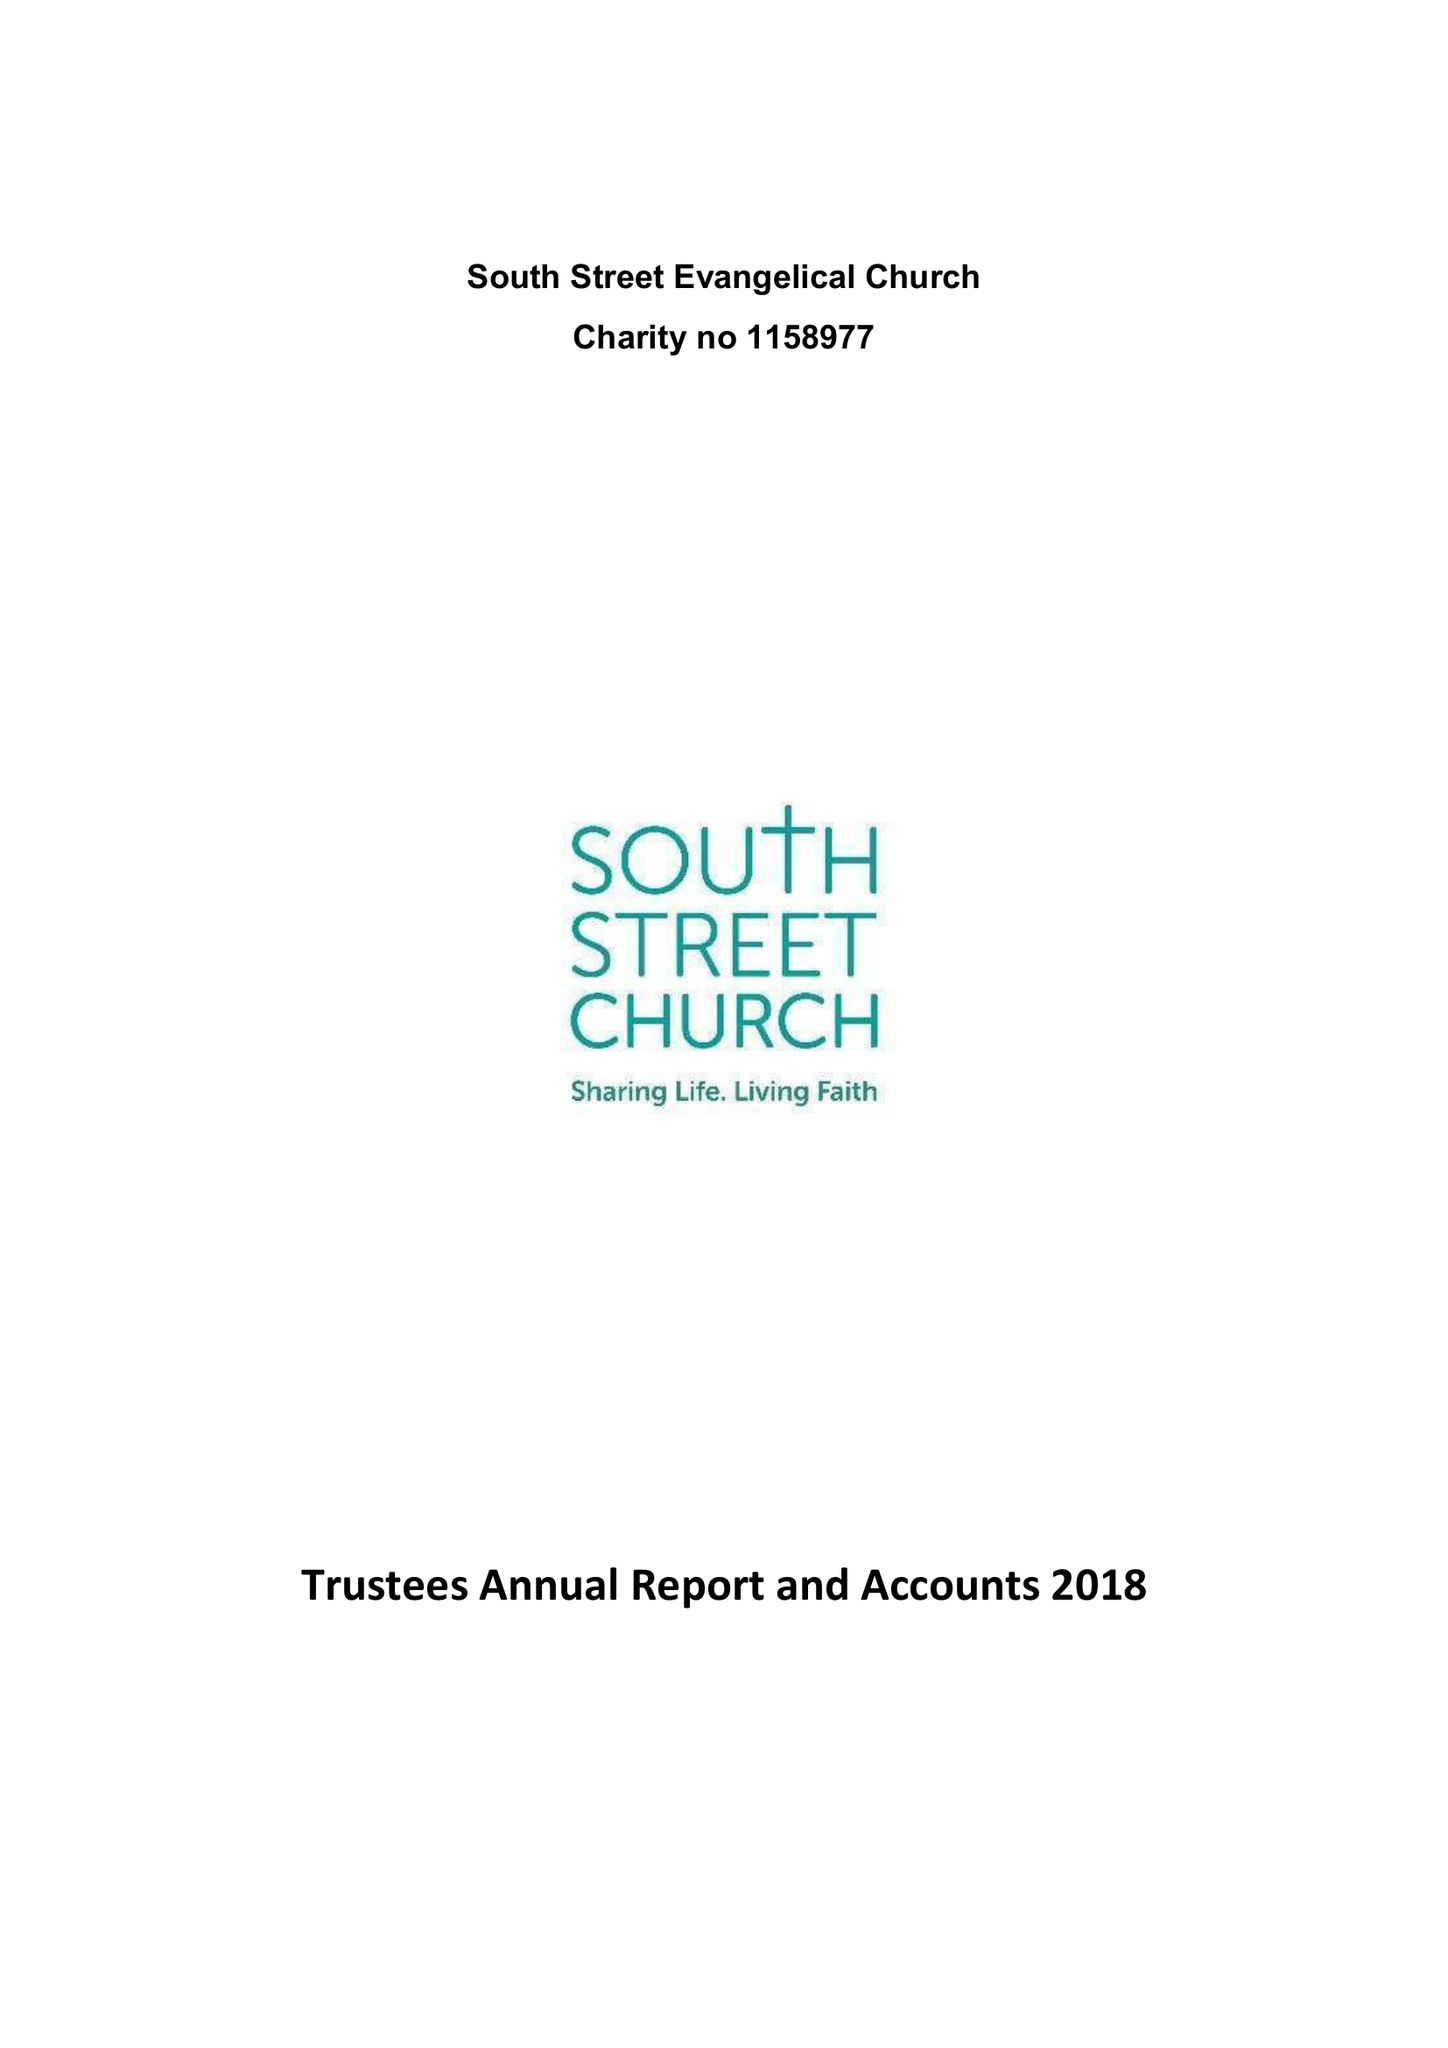What is the value for the charity_number?
Answer the question using a single word or phrase. 1158997 